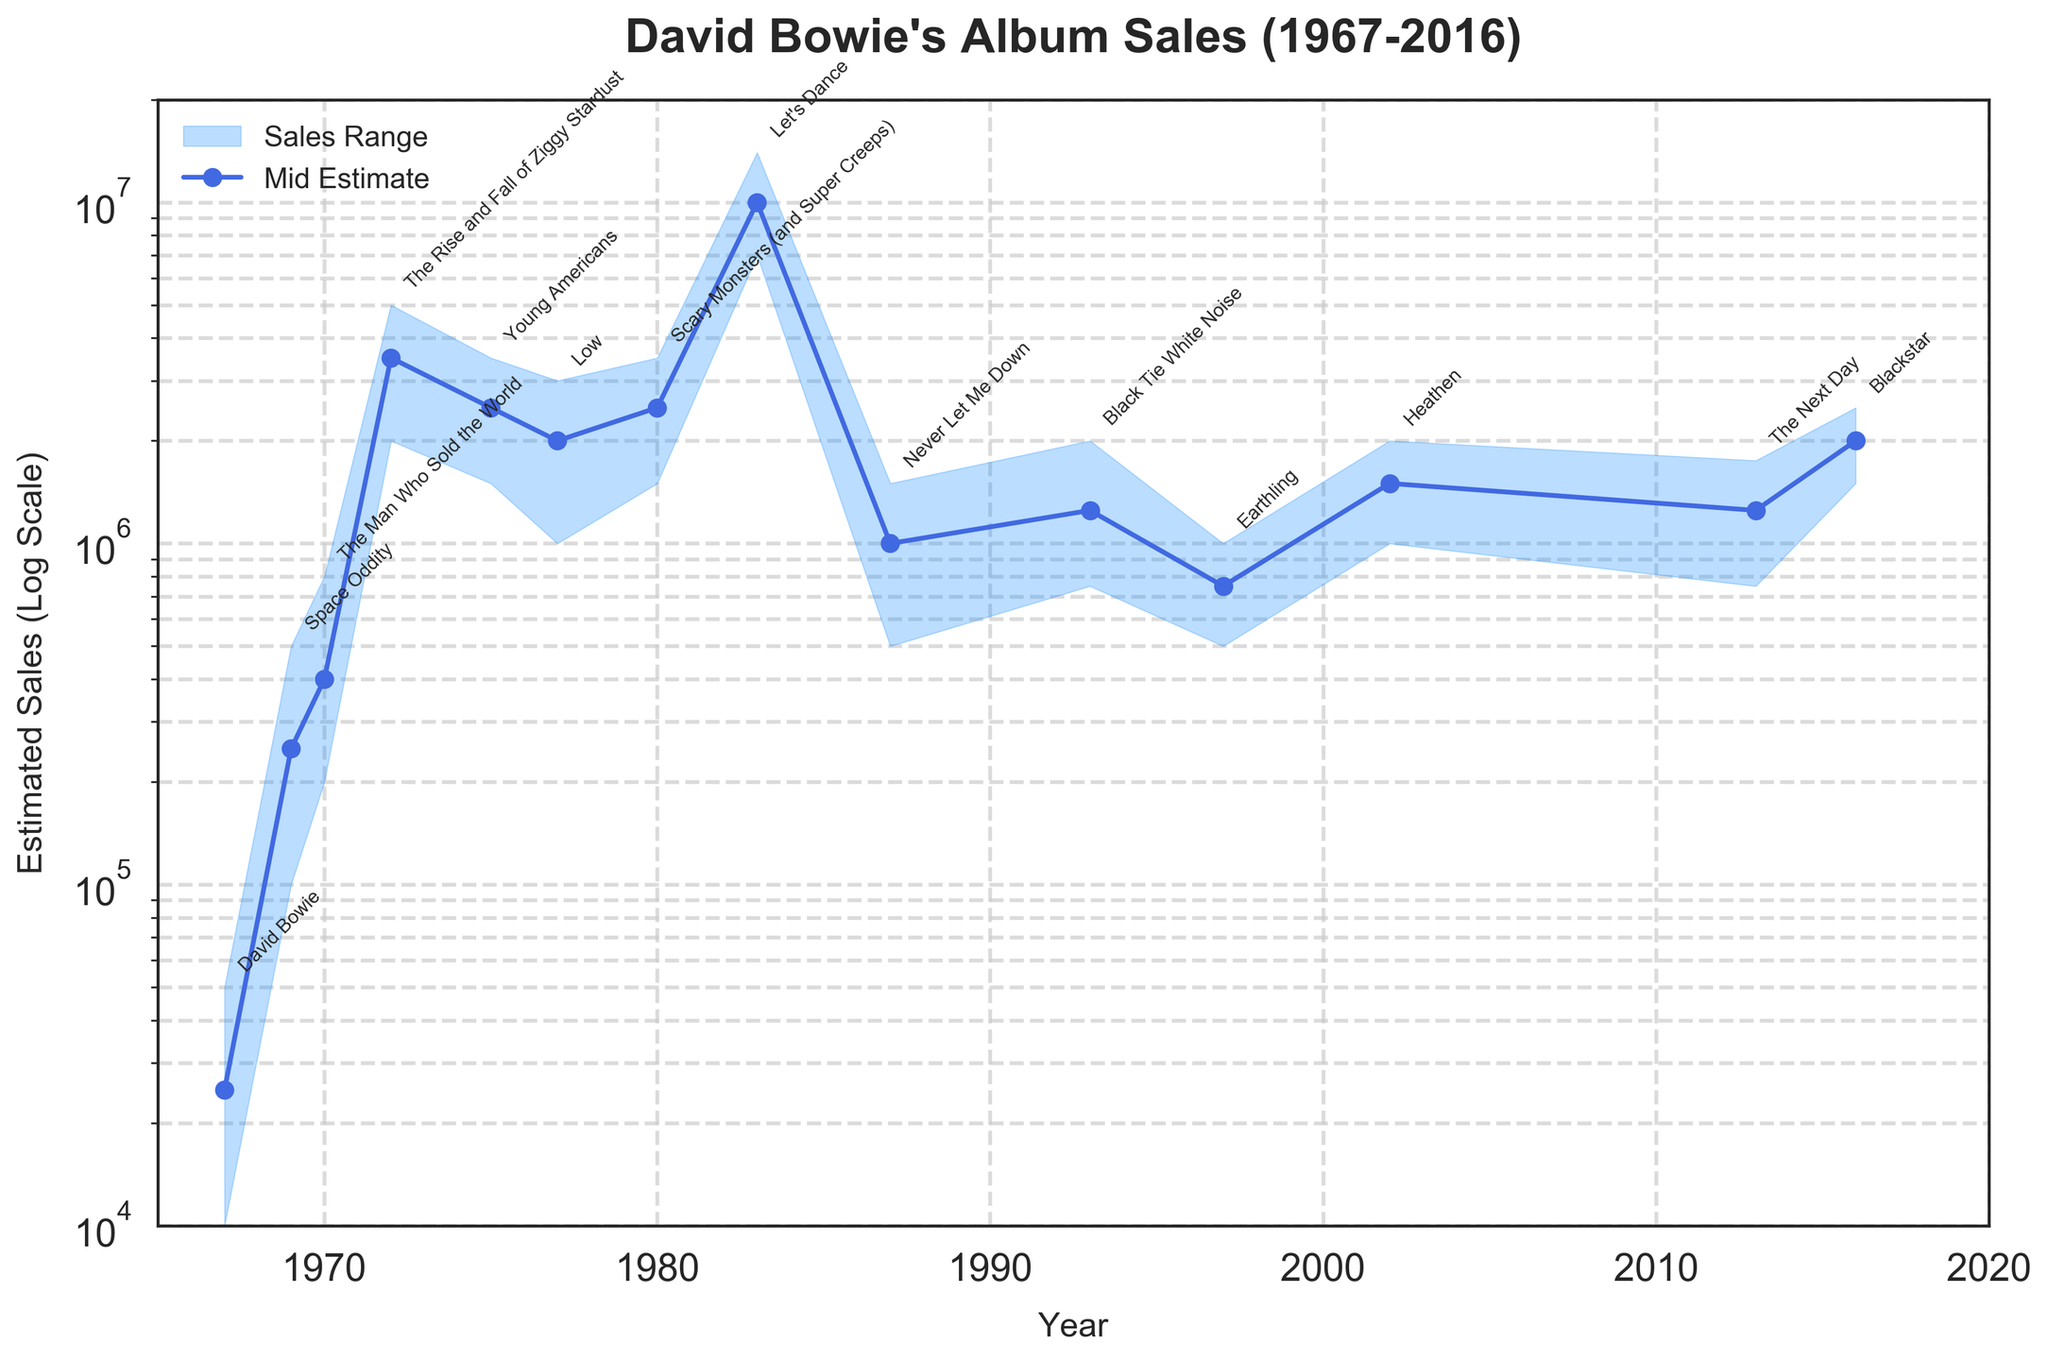Which album had the highest mid estimate sales? Observing the plotted mid estimates for each album, the highest value is around 10 million, corresponding to "Let's Dance" released in 1983.
Answer: "Let's Dance" In which year did David Bowie release an album with an estimated sales range between 1 million and 2 million? Identifying the albums and their sales ranges, "Low" (1977), "Earthling" (1997), and "Heathen" (2002) had this sales range.
Answer: 1977, 1997, 2002 What is the rate of increase in mid estimate sales from 1969's "Space Oddity" to 1972's "The Rise and Fall of Ziggy Stardust"? "Space Oddity" (1969) had mid estimates of 250,000, while "The Rise and Fall of Ziggy Stardust" (1972) had 3,500,000. The rate of increase is calculated by (3,500,000 - 250,000) / 250,000 * 100%.
Answer: 1300% Which album from the 1980s had higher mid estimate sales, "Scary Monsters (and Super Creeps)" or "Never Let Me Down"? Comparing the mid estimates for albums in the 1980s, "Scary Monsters (and Super Creeps)" (1980) had around 2.5 million, whereas "Never Let Me Down" (1987) had around 1 million.
Answer: "Scary Monsters (and Super Creeps)" What trend do you observe in the high estimate sales from the earliest album to the latest album in the data set? Over time, the high estimate sales increase significantly until 1983, after which they fluctuate and eventually decrease in later years, with "Let's Dance" (1983) peaking at 14 million.
Answer: Increasing until 1983, then fluctuating and decreasing How many albums had a high estimate sales figure of 2 million or more? By examining the high estimate sales values, "Space Oddity" (1969) through "Blackstar" (2016), except for "Never Let Me Down" and "Earthling," had high estimates of 2 million or more.
Answer: 10 albums Which album had the highest discrepancy between low and high estimate sales? The greatest disparity appears to be in "Let's Dance" (1983), where the difference is 14 million - 7 million = 7 million.
Answer: "Let's Dance" What is the general pattern of David Bowie's album sales after 1980 compared to before 1980? Before 1980, album sales show a growing trend. After 1980, there's variability with sales peaking in "Let's Dance" (1983) and then fluctuating with a general decline.
Answer: Fluctuating and declining after 1980 Which album's release followed "The Rise and Fall of Ziggy Stardust" based on the mid estimate sales? The next album released was "Young Americans" in 1975, with mid estimate sales around 2.5 million, following "The Rise and Fall of Ziggy Stardust" in 1972.
Answer: "Young Americans" 